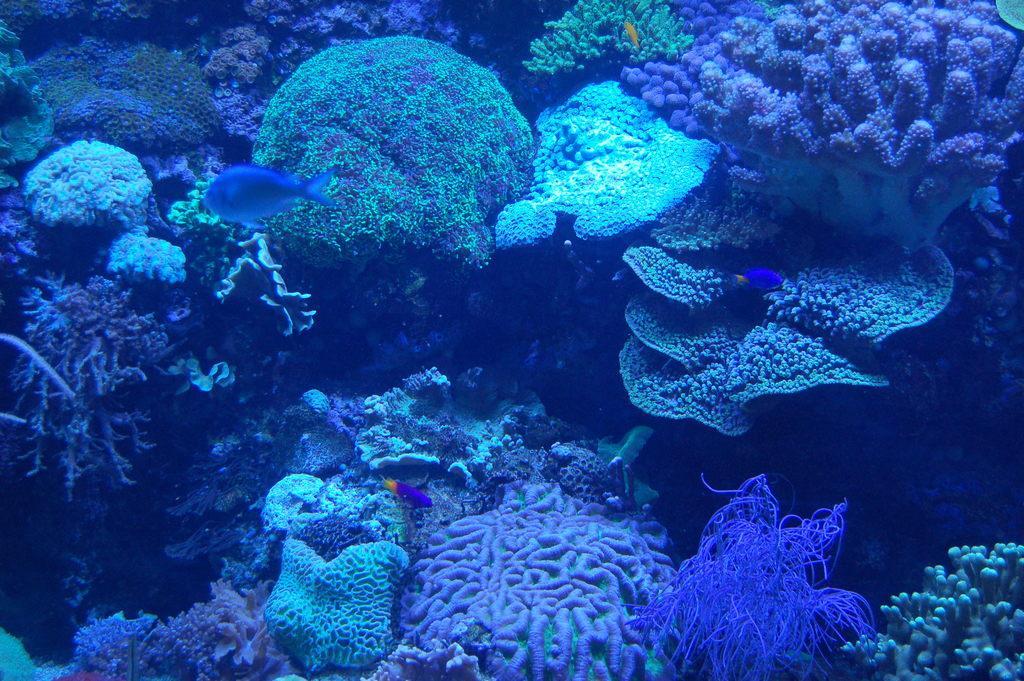Describe this image in one or two sentences. In this image we can see a coral reef and some fishes in the water. 